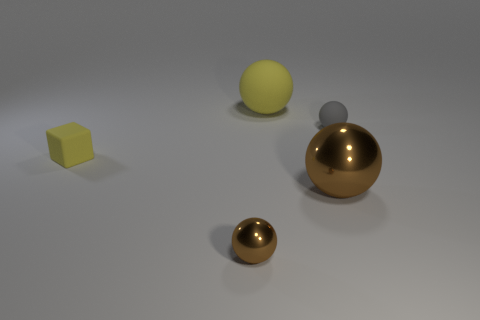What materials are the objects in the image likely made of? The objects appear to be made from various materials: the larger sphere and the smaller ball in the foreground have a metallic finish, suggesting they could be made of metal. The tiny brown sphere might be made of clay or plastic with a matte texture, while the two geometric shapes, the sphere and the cube, seem to have a rubber-like material with a matte finish. 